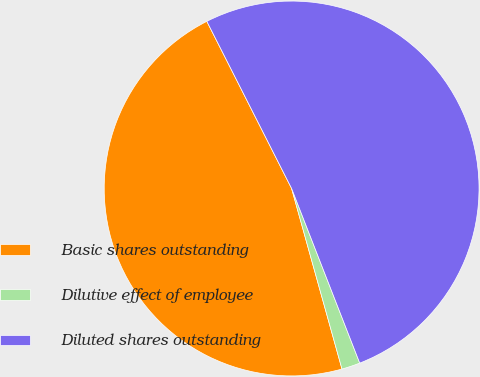<chart> <loc_0><loc_0><loc_500><loc_500><pie_chart><fcel>Basic shares outstanding<fcel>Dilutive effect of employee<fcel>Diluted shares outstanding<nl><fcel>46.86%<fcel>1.59%<fcel>51.55%<nl></chart> 